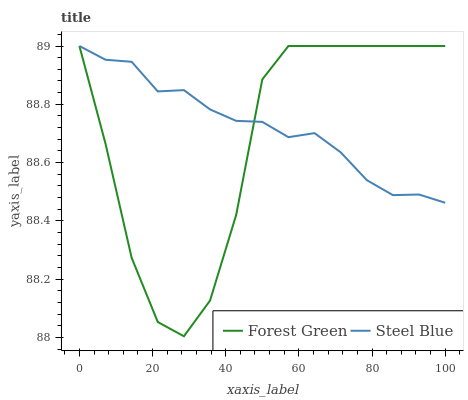Does Forest Green have the minimum area under the curve?
Answer yes or no. Yes. Does Steel Blue have the maximum area under the curve?
Answer yes or no. Yes. Does Steel Blue have the minimum area under the curve?
Answer yes or no. No. Is Steel Blue the smoothest?
Answer yes or no. Yes. Is Forest Green the roughest?
Answer yes or no. Yes. Is Steel Blue the roughest?
Answer yes or no. No. Does Forest Green have the lowest value?
Answer yes or no. Yes. Does Steel Blue have the lowest value?
Answer yes or no. No. Does Steel Blue have the highest value?
Answer yes or no. Yes. Does Steel Blue intersect Forest Green?
Answer yes or no. Yes. Is Steel Blue less than Forest Green?
Answer yes or no. No. Is Steel Blue greater than Forest Green?
Answer yes or no. No. 